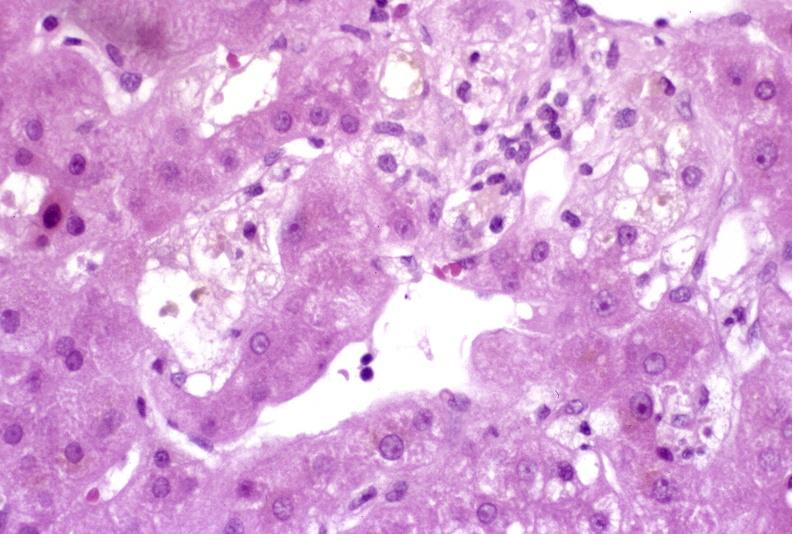s esophagus present?
Answer the question using a single word or phrase. No 